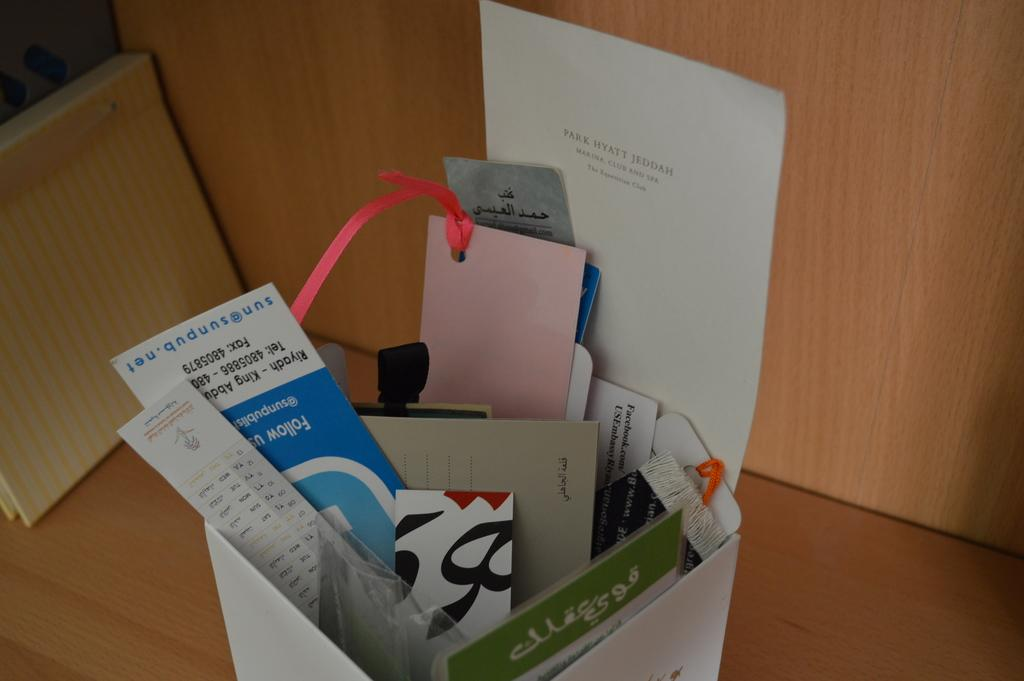<image>
Provide a brief description of the given image. Bin holding many pieces of paper including one that says Park Hyatt Jeddah. 